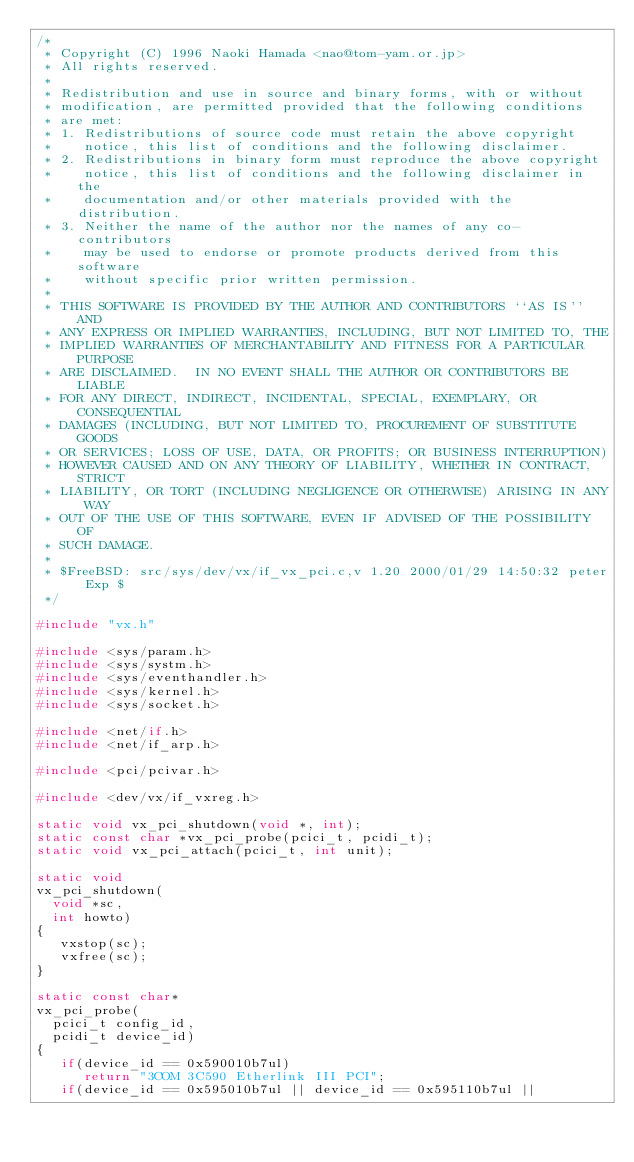<code> <loc_0><loc_0><loc_500><loc_500><_C_>/*
 * Copyright (C) 1996 Naoki Hamada <nao@tom-yam.or.jp>
 * All rights reserved.
 *
 * Redistribution and use in source and binary forms, with or without
 * modification, are permitted provided that the following conditions
 * are met:
 * 1. Redistributions of source code must retain the above copyright
 *    notice, this list of conditions and the following disclaimer.
 * 2. Redistributions in binary form must reproduce the above copyright
 *    notice, this list of conditions and the following disclaimer in the
 *    documentation and/or other materials provided with the distribution.
 * 3. Neither the name of the author nor the names of any co-contributors
 *    may be used to endorse or promote products derived from this software
 *    without specific prior written permission.
 *
 * THIS SOFTWARE IS PROVIDED BY THE AUTHOR AND CONTRIBUTORS ``AS IS'' AND
 * ANY EXPRESS OR IMPLIED WARRANTIES, INCLUDING, BUT NOT LIMITED TO, THE
 * IMPLIED WARRANTIES OF MERCHANTABILITY AND FITNESS FOR A PARTICULAR PURPOSE
 * ARE DISCLAIMED.  IN NO EVENT SHALL THE AUTHOR OR CONTRIBUTORS BE LIABLE
 * FOR ANY DIRECT, INDIRECT, INCIDENTAL, SPECIAL, EXEMPLARY, OR CONSEQUENTIAL
 * DAMAGES (INCLUDING, BUT NOT LIMITED TO, PROCUREMENT OF SUBSTITUTE GOODS
 * OR SERVICES; LOSS OF USE, DATA, OR PROFITS; OR BUSINESS INTERRUPTION)
 * HOWEVER CAUSED AND ON ANY THEORY OF LIABILITY, WHETHER IN CONTRACT, STRICT
 * LIABILITY, OR TORT (INCLUDING NEGLIGENCE OR OTHERWISE) ARISING IN ANY WAY
 * OUT OF THE USE OF THIS SOFTWARE, EVEN IF ADVISED OF THE POSSIBILITY OF
 * SUCH DAMAGE.
 *
 * $FreeBSD: src/sys/dev/vx/if_vx_pci.c,v 1.20 2000/01/29 14:50:32 peter Exp $
 */

#include "vx.h"

#include <sys/param.h>
#include <sys/systm.h>
#include <sys/eventhandler.h>
#include <sys/kernel.h>
#include <sys/socket.h>

#include <net/if.h>
#include <net/if_arp.h>

#include <pci/pcivar.h>

#include <dev/vx/if_vxreg.h>

static void vx_pci_shutdown(void *, int);
static const char *vx_pci_probe(pcici_t, pcidi_t);
static void vx_pci_attach(pcici_t, int unit);

static void
vx_pci_shutdown(
	void *sc,
	int howto)
{
   vxstop(sc); 
   vxfree(sc);
}

static const char*
vx_pci_probe(
	pcici_t config_id,
	pcidi_t device_id)
{
   if(device_id == 0x590010b7ul)
      return "3COM 3C590 Etherlink III PCI";
   if(device_id == 0x595010b7ul || device_id == 0x595110b7ul ||</code> 